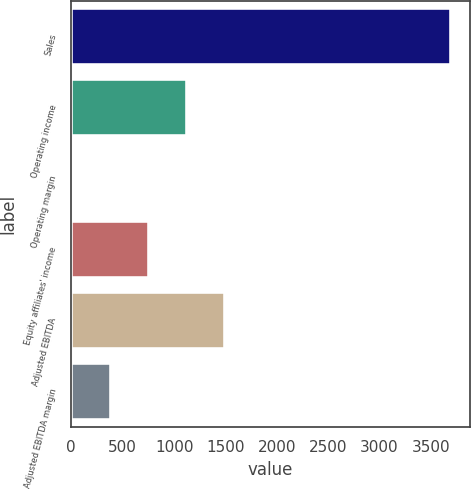<chart> <loc_0><loc_0><loc_500><loc_500><bar_chart><fcel>Sales<fcel>Operating income<fcel>Operating margin<fcel>Equity affiliates' income<fcel>Adjusted EBITDA<fcel>Adjusted EBITDA margin<nl><fcel>3694.5<fcel>1123.61<fcel>21.8<fcel>756.34<fcel>1490.88<fcel>389.07<nl></chart> 